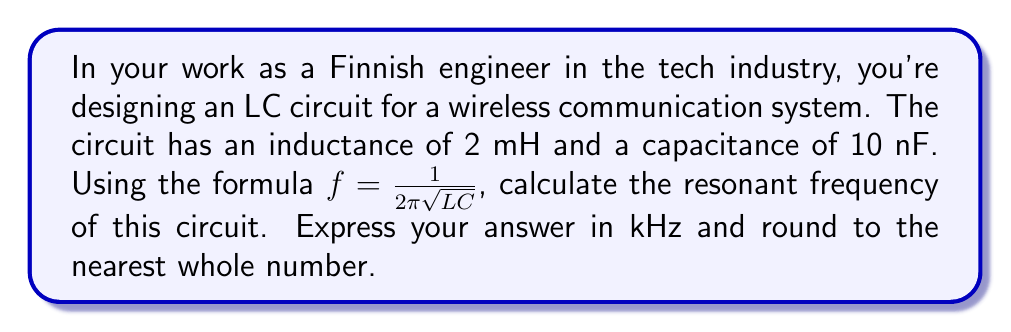Solve this math problem. Let's approach this step-by-step:

1) We're given the formula for the resonant frequency of an LC circuit:

   $f = \frac{1}{2\pi\sqrt{LC}}$

2) We know the values:
   L = 2 mH = $2 \times 10^{-3}$ H
   C = 10 nF = $10 \times 10^{-9}$ F

3) Let's substitute these into the formula:

   $f = \frac{1}{2\pi\sqrt{(2 \times 10^{-3})(10 \times 10^{-9})}}$

4) Simplify inside the square root:

   $f = \frac{1}{2\pi\sqrt{20 \times 10^{-12}}}$

5) Calculate the square root:

   $f = \frac{1}{2\pi\sqrt{20 \times 10^{-12}}} = \frac{1}{2\pi(4.47 \times 10^{-6})}$

6) Complete the calculation:

   $f = \frac{1}{2\pi(4.47 \times 10^{-6})} \approx 35,591.5$ Hz

7) Convert to kHz and round to the nearest whole number:

   $35,591.5$ Hz $\approx 35.6$ kHz $\approx 36$ kHz
Answer: 36 kHz 